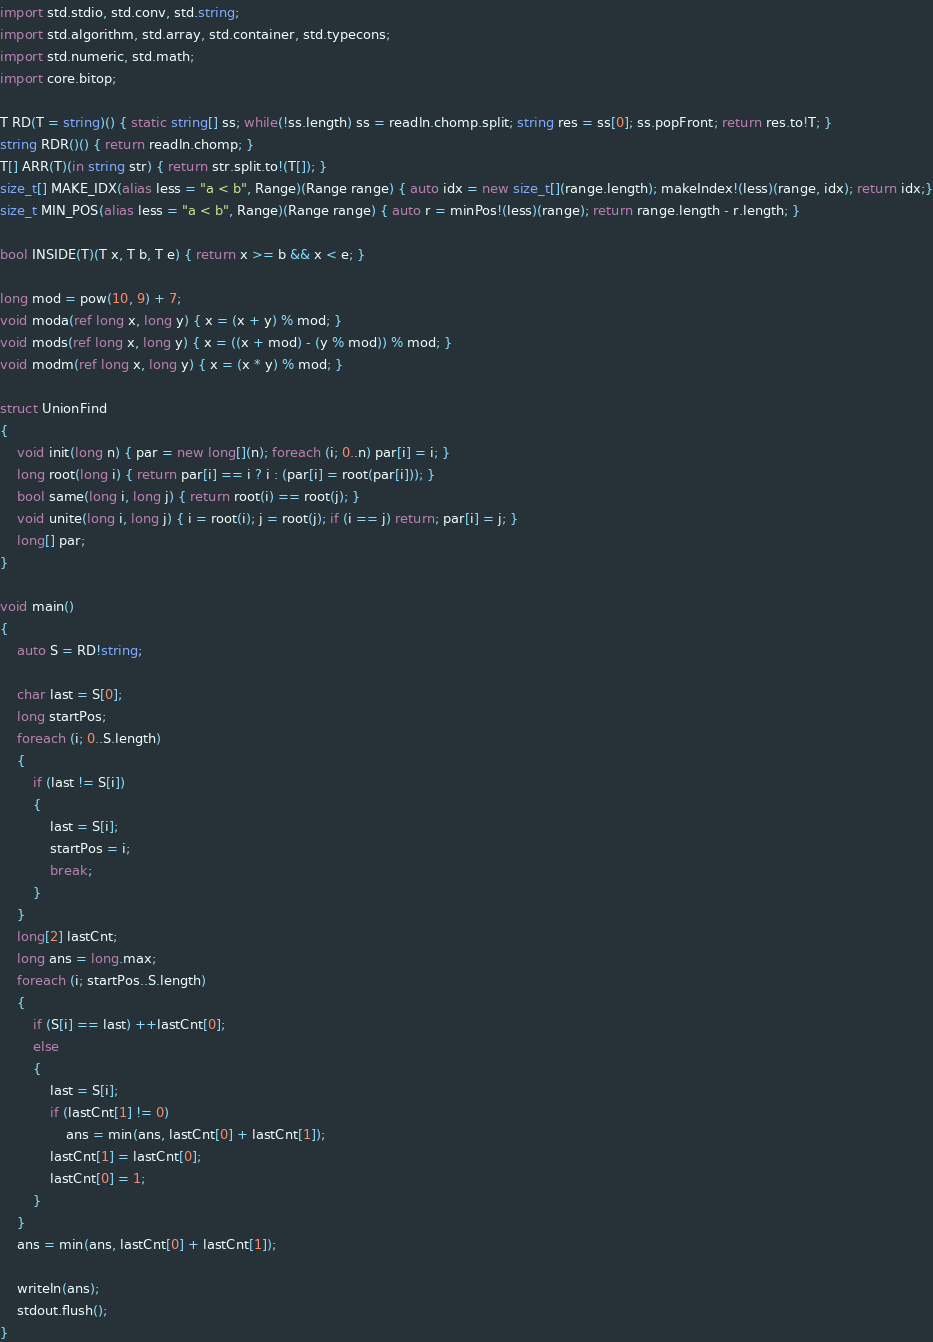Convert code to text. <code><loc_0><loc_0><loc_500><loc_500><_D_>import std.stdio, std.conv, std.string;
import std.algorithm, std.array, std.container, std.typecons;
import std.numeric, std.math;
import core.bitop;

T RD(T = string)() { static string[] ss; while(!ss.length) ss = readln.chomp.split; string res = ss[0]; ss.popFront; return res.to!T; }
string RDR()() { return readln.chomp; }
T[] ARR(T)(in string str) { return str.split.to!(T[]); }
size_t[] MAKE_IDX(alias less = "a < b", Range)(Range range) { auto idx = new size_t[](range.length); makeIndex!(less)(range, idx); return idx;}
size_t MIN_POS(alias less = "a < b", Range)(Range range) { auto r = minPos!(less)(range); return range.length - r.length; }

bool INSIDE(T)(T x, T b, T e) { return x >= b && x < e; }

long mod = pow(10, 9) + 7;
void moda(ref long x, long y) { x = (x + y) % mod; }
void mods(ref long x, long y) { x = ((x + mod) - (y % mod)) % mod; }
void modm(ref long x, long y) { x = (x * y) % mod; }

struct UnionFind
{
	void init(long n) { par = new long[](n); foreach (i; 0..n) par[i] = i; }
	long root(long i) { return par[i] == i ? i : (par[i] = root(par[i])); }
	bool same(long i, long j) { return root(i) == root(j); }
	void unite(long i, long j) { i = root(i); j = root(j); if (i == j) return; par[i] = j; }
	long[] par;
}

void main()
{
	auto S = RD!string;

	char last = S[0];
	long startPos;
	foreach (i; 0..S.length)
	{
		if (last != S[i])
		{
			last = S[i];
			startPos = i;
			break;
		}
	}
	long[2] lastCnt;
	long ans = long.max;
	foreach (i; startPos..S.length)
	{
		if (S[i] == last) ++lastCnt[0];
		else
		{
			last = S[i];
			if (lastCnt[1] != 0)
				ans = min(ans, lastCnt[0] + lastCnt[1]);
			lastCnt[1] = lastCnt[0];
			lastCnt[0] = 1;
		}
	}
	ans = min(ans, lastCnt[0] + lastCnt[1]);

	writeln(ans);
	stdout.flush();
}</code> 